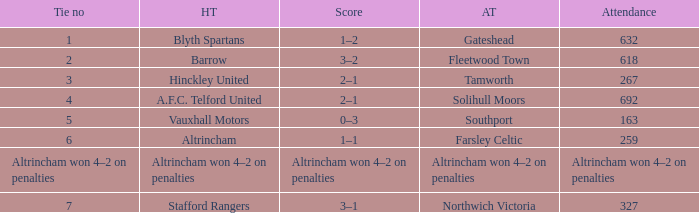Parse the full table. {'header': ['Tie no', 'HT', 'Score', 'AT', 'Attendance'], 'rows': [['1', 'Blyth Spartans', '1–2', 'Gateshead', '632'], ['2', 'Barrow', '3–2', 'Fleetwood Town', '618'], ['3', 'Hinckley United', '2–1', 'Tamworth', '267'], ['4', 'A.F.C. Telford United', '2–1', 'Solihull Moors', '692'], ['5', 'Vauxhall Motors', '0–3', 'Southport', '163'], ['6', 'Altrincham', '1–1', 'Farsley Celtic', '259'], ['Altrincham won 4–2 on penalties', 'Altrincham won 4–2 on penalties', 'Altrincham won 4–2 on penalties', 'Altrincham won 4–2 on penalties', 'Altrincham won 4–2 on penalties'], ['7', 'Stafford Rangers', '3–1', 'Northwich Victoria', '327']]} What was the attendance for the away team Solihull Moors? 692.0. 